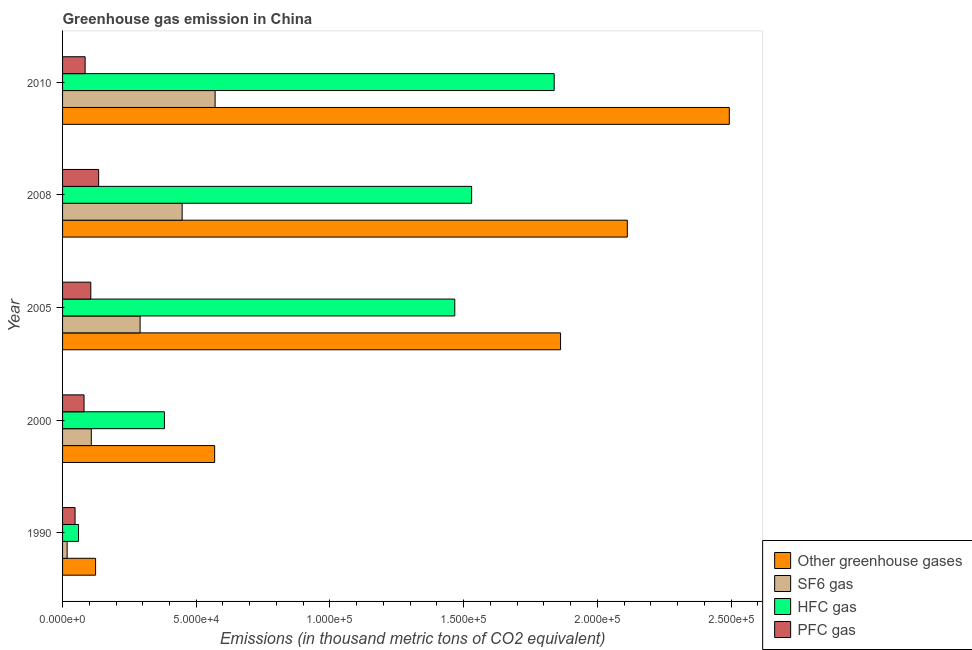How many bars are there on the 3rd tick from the bottom?
Keep it short and to the point. 4. What is the label of the 1st group of bars from the top?
Provide a short and direct response. 2010. What is the emission of hfc gas in 1990?
Offer a terse response. 5970.1. Across all years, what is the maximum emission of sf6 gas?
Keep it short and to the point. 5.71e+04. Across all years, what is the minimum emission of hfc gas?
Keep it short and to the point. 5970.1. In which year was the emission of pfc gas maximum?
Offer a terse response. 2008. What is the total emission of hfc gas in the graph?
Ensure brevity in your answer.  5.28e+05. What is the difference between the emission of greenhouse gases in 2008 and that in 2010?
Ensure brevity in your answer.  -3.81e+04. What is the difference between the emission of hfc gas in 2000 and the emission of sf6 gas in 2008?
Ensure brevity in your answer.  -6632.2. What is the average emission of sf6 gas per year?
Your answer should be compact. 2.86e+04. In the year 2010, what is the difference between the emission of hfc gas and emission of greenhouse gases?
Your answer should be compact. -6.55e+04. In how many years, is the emission of sf6 gas greater than 50000 thousand metric tons?
Provide a succinct answer. 1. What is the ratio of the emission of sf6 gas in 1990 to that in 2008?
Your response must be concise. 0.04. Is the emission of pfc gas in 1990 less than that in 2000?
Provide a short and direct response. Yes. Is the difference between the emission of pfc gas in 1990 and 2008 greater than the difference between the emission of sf6 gas in 1990 and 2008?
Make the answer very short. Yes. What is the difference between the highest and the second highest emission of pfc gas?
Your response must be concise. 2937.8. What is the difference between the highest and the lowest emission of sf6 gas?
Your answer should be compact. 5.53e+04. In how many years, is the emission of greenhouse gases greater than the average emission of greenhouse gases taken over all years?
Offer a very short reply. 3. Is the sum of the emission of sf6 gas in 2008 and 2010 greater than the maximum emission of hfc gas across all years?
Make the answer very short. No. What does the 2nd bar from the top in 2010 represents?
Your answer should be compact. HFC gas. What does the 2nd bar from the bottom in 2005 represents?
Your response must be concise. SF6 gas. How many bars are there?
Make the answer very short. 20. How many years are there in the graph?
Your answer should be compact. 5. What is the difference between two consecutive major ticks on the X-axis?
Give a very brief answer. 5.00e+04. Does the graph contain grids?
Your response must be concise. No. Where does the legend appear in the graph?
Your response must be concise. Bottom right. How many legend labels are there?
Make the answer very short. 4. What is the title of the graph?
Provide a succinct answer. Greenhouse gas emission in China. What is the label or title of the X-axis?
Ensure brevity in your answer.  Emissions (in thousand metric tons of CO2 equivalent). What is the label or title of the Y-axis?
Offer a terse response. Year. What is the Emissions (in thousand metric tons of CO2 equivalent) in Other greenhouse gases in 1990?
Your answer should be compact. 1.24e+04. What is the Emissions (in thousand metric tons of CO2 equivalent) in SF6 gas in 1990?
Give a very brief answer. 1708.6. What is the Emissions (in thousand metric tons of CO2 equivalent) of HFC gas in 1990?
Keep it short and to the point. 5970.1. What is the Emissions (in thousand metric tons of CO2 equivalent) of PFC gas in 1990?
Give a very brief answer. 4674.5. What is the Emissions (in thousand metric tons of CO2 equivalent) of Other greenhouse gases in 2000?
Your answer should be very brief. 5.69e+04. What is the Emissions (in thousand metric tons of CO2 equivalent) in SF6 gas in 2000?
Your response must be concise. 1.08e+04. What is the Emissions (in thousand metric tons of CO2 equivalent) of HFC gas in 2000?
Your answer should be compact. 3.81e+04. What is the Emissions (in thousand metric tons of CO2 equivalent) in PFC gas in 2000?
Offer a very short reply. 8034.4. What is the Emissions (in thousand metric tons of CO2 equivalent) in Other greenhouse gases in 2005?
Your answer should be very brief. 1.86e+05. What is the Emissions (in thousand metric tons of CO2 equivalent) in SF6 gas in 2005?
Offer a very short reply. 2.90e+04. What is the Emissions (in thousand metric tons of CO2 equivalent) of HFC gas in 2005?
Offer a very short reply. 1.47e+05. What is the Emissions (in thousand metric tons of CO2 equivalent) in PFC gas in 2005?
Give a very brief answer. 1.06e+04. What is the Emissions (in thousand metric tons of CO2 equivalent) of Other greenhouse gases in 2008?
Give a very brief answer. 2.11e+05. What is the Emissions (in thousand metric tons of CO2 equivalent) in SF6 gas in 2008?
Provide a short and direct response. 4.47e+04. What is the Emissions (in thousand metric tons of CO2 equivalent) in HFC gas in 2008?
Your answer should be compact. 1.53e+05. What is the Emissions (in thousand metric tons of CO2 equivalent) of PFC gas in 2008?
Give a very brief answer. 1.35e+04. What is the Emissions (in thousand metric tons of CO2 equivalent) in Other greenhouse gases in 2010?
Your response must be concise. 2.49e+05. What is the Emissions (in thousand metric tons of CO2 equivalent) in SF6 gas in 2010?
Your response must be concise. 5.71e+04. What is the Emissions (in thousand metric tons of CO2 equivalent) in HFC gas in 2010?
Provide a succinct answer. 1.84e+05. What is the Emissions (in thousand metric tons of CO2 equivalent) in PFC gas in 2010?
Give a very brief answer. 8438. Across all years, what is the maximum Emissions (in thousand metric tons of CO2 equivalent) of Other greenhouse gases?
Your response must be concise. 2.49e+05. Across all years, what is the maximum Emissions (in thousand metric tons of CO2 equivalent) in SF6 gas?
Give a very brief answer. 5.71e+04. Across all years, what is the maximum Emissions (in thousand metric tons of CO2 equivalent) in HFC gas?
Make the answer very short. 1.84e+05. Across all years, what is the maximum Emissions (in thousand metric tons of CO2 equivalent) of PFC gas?
Ensure brevity in your answer.  1.35e+04. Across all years, what is the minimum Emissions (in thousand metric tons of CO2 equivalent) of Other greenhouse gases?
Give a very brief answer. 1.24e+04. Across all years, what is the minimum Emissions (in thousand metric tons of CO2 equivalent) in SF6 gas?
Provide a succinct answer. 1708.6. Across all years, what is the minimum Emissions (in thousand metric tons of CO2 equivalent) of HFC gas?
Make the answer very short. 5970.1. Across all years, what is the minimum Emissions (in thousand metric tons of CO2 equivalent) in PFC gas?
Provide a short and direct response. 4674.5. What is the total Emissions (in thousand metric tons of CO2 equivalent) of Other greenhouse gases in the graph?
Ensure brevity in your answer.  7.16e+05. What is the total Emissions (in thousand metric tons of CO2 equivalent) of SF6 gas in the graph?
Provide a succinct answer. 1.43e+05. What is the total Emissions (in thousand metric tons of CO2 equivalent) of HFC gas in the graph?
Offer a terse response. 5.28e+05. What is the total Emissions (in thousand metric tons of CO2 equivalent) of PFC gas in the graph?
Give a very brief answer. 4.52e+04. What is the difference between the Emissions (in thousand metric tons of CO2 equivalent) of Other greenhouse gases in 1990 and that in 2000?
Your answer should be very brief. -4.45e+04. What is the difference between the Emissions (in thousand metric tons of CO2 equivalent) in SF6 gas in 1990 and that in 2000?
Provide a short and direct response. -9045. What is the difference between the Emissions (in thousand metric tons of CO2 equivalent) in HFC gas in 1990 and that in 2000?
Your answer should be compact. -3.21e+04. What is the difference between the Emissions (in thousand metric tons of CO2 equivalent) of PFC gas in 1990 and that in 2000?
Give a very brief answer. -3359.9. What is the difference between the Emissions (in thousand metric tons of CO2 equivalent) in Other greenhouse gases in 1990 and that in 2005?
Offer a terse response. -1.74e+05. What is the difference between the Emissions (in thousand metric tons of CO2 equivalent) of SF6 gas in 1990 and that in 2005?
Keep it short and to the point. -2.73e+04. What is the difference between the Emissions (in thousand metric tons of CO2 equivalent) of HFC gas in 1990 and that in 2005?
Give a very brief answer. -1.41e+05. What is the difference between the Emissions (in thousand metric tons of CO2 equivalent) in PFC gas in 1990 and that in 2005?
Your answer should be compact. -5888.3. What is the difference between the Emissions (in thousand metric tons of CO2 equivalent) in Other greenhouse gases in 1990 and that in 2008?
Your answer should be very brief. -1.99e+05. What is the difference between the Emissions (in thousand metric tons of CO2 equivalent) of SF6 gas in 1990 and that in 2008?
Provide a succinct answer. -4.30e+04. What is the difference between the Emissions (in thousand metric tons of CO2 equivalent) of HFC gas in 1990 and that in 2008?
Your answer should be very brief. -1.47e+05. What is the difference between the Emissions (in thousand metric tons of CO2 equivalent) in PFC gas in 1990 and that in 2008?
Your answer should be very brief. -8826.1. What is the difference between the Emissions (in thousand metric tons of CO2 equivalent) in Other greenhouse gases in 1990 and that in 2010?
Give a very brief answer. -2.37e+05. What is the difference between the Emissions (in thousand metric tons of CO2 equivalent) in SF6 gas in 1990 and that in 2010?
Give a very brief answer. -5.53e+04. What is the difference between the Emissions (in thousand metric tons of CO2 equivalent) in HFC gas in 1990 and that in 2010?
Your answer should be very brief. -1.78e+05. What is the difference between the Emissions (in thousand metric tons of CO2 equivalent) of PFC gas in 1990 and that in 2010?
Provide a short and direct response. -3763.5. What is the difference between the Emissions (in thousand metric tons of CO2 equivalent) in Other greenhouse gases in 2000 and that in 2005?
Offer a terse response. -1.29e+05. What is the difference between the Emissions (in thousand metric tons of CO2 equivalent) in SF6 gas in 2000 and that in 2005?
Your answer should be very brief. -1.82e+04. What is the difference between the Emissions (in thousand metric tons of CO2 equivalent) in HFC gas in 2000 and that in 2005?
Your response must be concise. -1.09e+05. What is the difference between the Emissions (in thousand metric tons of CO2 equivalent) in PFC gas in 2000 and that in 2005?
Your answer should be compact. -2528.4. What is the difference between the Emissions (in thousand metric tons of CO2 equivalent) in Other greenhouse gases in 2000 and that in 2008?
Provide a short and direct response. -1.54e+05. What is the difference between the Emissions (in thousand metric tons of CO2 equivalent) of SF6 gas in 2000 and that in 2008?
Keep it short and to the point. -3.40e+04. What is the difference between the Emissions (in thousand metric tons of CO2 equivalent) in HFC gas in 2000 and that in 2008?
Provide a short and direct response. -1.15e+05. What is the difference between the Emissions (in thousand metric tons of CO2 equivalent) of PFC gas in 2000 and that in 2008?
Keep it short and to the point. -5466.2. What is the difference between the Emissions (in thousand metric tons of CO2 equivalent) of Other greenhouse gases in 2000 and that in 2010?
Offer a very short reply. -1.92e+05. What is the difference between the Emissions (in thousand metric tons of CO2 equivalent) of SF6 gas in 2000 and that in 2010?
Your response must be concise. -4.63e+04. What is the difference between the Emissions (in thousand metric tons of CO2 equivalent) of HFC gas in 2000 and that in 2010?
Keep it short and to the point. -1.46e+05. What is the difference between the Emissions (in thousand metric tons of CO2 equivalent) of PFC gas in 2000 and that in 2010?
Provide a short and direct response. -403.6. What is the difference between the Emissions (in thousand metric tons of CO2 equivalent) in Other greenhouse gases in 2005 and that in 2008?
Your response must be concise. -2.50e+04. What is the difference between the Emissions (in thousand metric tons of CO2 equivalent) in SF6 gas in 2005 and that in 2008?
Your answer should be compact. -1.57e+04. What is the difference between the Emissions (in thousand metric tons of CO2 equivalent) of HFC gas in 2005 and that in 2008?
Keep it short and to the point. -6309. What is the difference between the Emissions (in thousand metric tons of CO2 equivalent) of PFC gas in 2005 and that in 2008?
Offer a very short reply. -2937.8. What is the difference between the Emissions (in thousand metric tons of CO2 equivalent) in Other greenhouse gases in 2005 and that in 2010?
Provide a short and direct response. -6.31e+04. What is the difference between the Emissions (in thousand metric tons of CO2 equivalent) of SF6 gas in 2005 and that in 2010?
Ensure brevity in your answer.  -2.81e+04. What is the difference between the Emissions (in thousand metric tons of CO2 equivalent) of HFC gas in 2005 and that in 2010?
Offer a terse response. -3.72e+04. What is the difference between the Emissions (in thousand metric tons of CO2 equivalent) in PFC gas in 2005 and that in 2010?
Provide a short and direct response. 2124.8. What is the difference between the Emissions (in thousand metric tons of CO2 equivalent) of Other greenhouse gases in 2008 and that in 2010?
Your answer should be compact. -3.81e+04. What is the difference between the Emissions (in thousand metric tons of CO2 equivalent) of SF6 gas in 2008 and that in 2010?
Keep it short and to the point. -1.23e+04. What is the difference between the Emissions (in thousand metric tons of CO2 equivalent) of HFC gas in 2008 and that in 2010?
Make the answer very short. -3.09e+04. What is the difference between the Emissions (in thousand metric tons of CO2 equivalent) in PFC gas in 2008 and that in 2010?
Your response must be concise. 5062.6. What is the difference between the Emissions (in thousand metric tons of CO2 equivalent) of Other greenhouse gases in 1990 and the Emissions (in thousand metric tons of CO2 equivalent) of SF6 gas in 2000?
Your answer should be very brief. 1599.6. What is the difference between the Emissions (in thousand metric tons of CO2 equivalent) of Other greenhouse gases in 1990 and the Emissions (in thousand metric tons of CO2 equivalent) of HFC gas in 2000?
Offer a very short reply. -2.57e+04. What is the difference between the Emissions (in thousand metric tons of CO2 equivalent) in Other greenhouse gases in 1990 and the Emissions (in thousand metric tons of CO2 equivalent) in PFC gas in 2000?
Provide a short and direct response. 4318.8. What is the difference between the Emissions (in thousand metric tons of CO2 equivalent) in SF6 gas in 1990 and the Emissions (in thousand metric tons of CO2 equivalent) in HFC gas in 2000?
Your response must be concise. -3.64e+04. What is the difference between the Emissions (in thousand metric tons of CO2 equivalent) in SF6 gas in 1990 and the Emissions (in thousand metric tons of CO2 equivalent) in PFC gas in 2000?
Offer a terse response. -6325.8. What is the difference between the Emissions (in thousand metric tons of CO2 equivalent) in HFC gas in 1990 and the Emissions (in thousand metric tons of CO2 equivalent) in PFC gas in 2000?
Provide a succinct answer. -2064.3. What is the difference between the Emissions (in thousand metric tons of CO2 equivalent) of Other greenhouse gases in 1990 and the Emissions (in thousand metric tons of CO2 equivalent) of SF6 gas in 2005?
Your answer should be compact. -1.66e+04. What is the difference between the Emissions (in thousand metric tons of CO2 equivalent) in Other greenhouse gases in 1990 and the Emissions (in thousand metric tons of CO2 equivalent) in HFC gas in 2005?
Keep it short and to the point. -1.34e+05. What is the difference between the Emissions (in thousand metric tons of CO2 equivalent) of Other greenhouse gases in 1990 and the Emissions (in thousand metric tons of CO2 equivalent) of PFC gas in 2005?
Ensure brevity in your answer.  1790.4. What is the difference between the Emissions (in thousand metric tons of CO2 equivalent) of SF6 gas in 1990 and the Emissions (in thousand metric tons of CO2 equivalent) of HFC gas in 2005?
Ensure brevity in your answer.  -1.45e+05. What is the difference between the Emissions (in thousand metric tons of CO2 equivalent) of SF6 gas in 1990 and the Emissions (in thousand metric tons of CO2 equivalent) of PFC gas in 2005?
Provide a succinct answer. -8854.2. What is the difference between the Emissions (in thousand metric tons of CO2 equivalent) of HFC gas in 1990 and the Emissions (in thousand metric tons of CO2 equivalent) of PFC gas in 2005?
Offer a terse response. -4592.7. What is the difference between the Emissions (in thousand metric tons of CO2 equivalent) in Other greenhouse gases in 1990 and the Emissions (in thousand metric tons of CO2 equivalent) in SF6 gas in 2008?
Your response must be concise. -3.24e+04. What is the difference between the Emissions (in thousand metric tons of CO2 equivalent) in Other greenhouse gases in 1990 and the Emissions (in thousand metric tons of CO2 equivalent) in HFC gas in 2008?
Ensure brevity in your answer.  -1.41e+05. What is the difference between the Emissions (in thousand metric tons of CO2 equivalent) in Other greenhouse gases in 1990 and the Emissions (in thousand metric tons of CO2 equivalent) in PFC gas in 2008?
Offer a terse response. -1147.4. What is the difference between the Emissions (in thousand metric tons of CO2 equivalent) in SF6 gas in 1990 and the Emissions (in thousand metric tons of CO2 equivalent) in HFC gas in 2008?
Make the answer very short. -1.51e+05. What is the difference between the Emissions (in thousand metric tons of CO2 equivalent) of SF6 gas in 1990 and the Emissions (in thousand metric tons of CO2 equivalent) of PFC gas in 2008?
Your answer should be compact. -1.18e+04. What is the difference between the Emissions (in thousand metric tons of CO2 equivalent) of HFC gas in 1990 and the Emissions (in thousand metric tons of CO2 equivalent) of PFC gas in 2008?
Your answer should be compact. -7530.5. What is the difference between the Emissions (in thousand metric tons of CO2 equivalent) in Other greenhouse gases in 1990 and the Emissions (in thousand metric tons of CO2 equivalent) in SF6 gas in 2010?
Provide a short and direct response. -4.47e+04. What is the difference between the Emissions (in thousand metric tons of CO2 equivalent) of Other greenhouse gases in 1990 and the Emissions (in thousand metric tons of CO2 equivalent) of HFC gas in 2010?
Keep it short and to the point. -1.72e+05. What is the difference between the Emissions (in thousand metric tons of CO2 equivalent) of Other greenhouse gases in 1990 and the Emissions (in thousand metric tons of CO2 equivalent) of PFC gas in 2010?
Ensure brevity in your answer.  3915.2. What is the difference between the Emissions (in thousand metric tons of CO2 equivalent) in SF6 gas in 1990 and the Emissions (in thousand metric tons of CO2 equivalent) in HFC gas in 2010?
Provide a short and direct response. -1.82e+05. What is the difference between the Emissions (in thousand metric tons of CO2 equivalent) of SF6 gas in 1990 and the Emissions (in thousand metric tons of CO2 equivalent) of PFC gas in 2010?
Provide a succinct answer. -6729.4. What is the difference between the Emissions (in thousand metric tons of CO2 equivalent) of HFC gas in 1990 and the Emissions (in thousand metric tons of CO2 equivalent) of PFC gas in 2010?
Your answer should be very brief. -2467.9. What is the difference between the Emissions (in thousand metric tons of CO2 equivalent) of Other greenhouse gases in 2000 and the Emissions (in thousand metric tons of CO2 equivalent) of SF6 gas in 2005?
Give a very brief answer. 2.79e+04. What is the difference between the Emissions (in thousand metric tons of CO2 equivalent) in Other greenhouse gases in 2000 and the Emissions (in thousand metric tons of CO2 equivalent) in HFC gas in 2005?
Make the answer very short. -8.98e+04. What is the difference between the Emissions (in thousand metric tons of CO2 equivalent) in Other greenhouse gases in 2000 and the Emissions (in thousand metric tons of CO2 equivalent) in PFC gas in 2005?
Give a very brief answer. 4.63e+04. What is the difference between the Emissions (in thousand metric tons of CO2 equivalent) in SF6 gas in 2000 and the Emissions (in thousand metric tons of CO2 equivalent) in HFC gas in 2005?
Offer a very short reply. -1.36e+05. What is the difference between the Emissions (in thousand metric tons of CO2 equivalent) in SF6 gas in 2000 and the Emissions (in thousand metric tons of CO2 equivalent) in PFC gas in 2005?
Provide a succinct answer. 190.8. What is the difference between the Emissions (in thousand metric tons of CO2 equivalent) of HFC gas in 2000 and the Emissions (in thousand metric tons of CO2 equivalent) of PFC gas in 2005?
Your answer should be very brief. 2.75e+04. What is the difference between the Emissions (in thousand metric tons of CO2 equivalent) in Other greenhouse gases in 2000 and the Emissions (in thousand metric tons of CO2 equivalent) in SF6 gas in 2008?
Your answer should be very brief. 1.22e+04. What is the difference between the Emissions (in thousand metric tons of CO2 equivalent) in Other greenhouse gases in 2000 and the Emissions (in thousand metric tons of CO2 equivalent) in HFC gas in 2008?
Your response must be concise. -9.61e+04. What is the difference between the Emissions (in thousand metric tons of CO2 equivalent) in Other greenhouse gases in 2000 and the Emissions (in thousand metric tons of CO2 equivalent) in PFC gas in 2008?
Make the answer very short. 4.34e+04. What is the difference between the Emissions (in thousand metric tons of CO2 equivalent) in SF6 gas in 2000 and the Emissions (in thousand metric tons of CO2 equivalent) in HFC gas in 2008?
Provide a succinct answer. -1.42e+05. What is the difference between the Emissions (in thousand metric tons of CO2 equivalent) in SF6 gas in 2000 and the Emissions (in thousand metric tons of CO2 equivalent) in PFC gas in 2008?
Keep it short and to the point. -2747. What is the difference between the Emissions (in thousand metric tons of CO2 equivalent) of HFC gas in 2000 and the Emissions (in thousand metric tons of CO2 equivalent) of PFC gas in 2008?
Provide a short and direct response. 2.46e+04. What is the difference between the Emissions (in thousand metric tons of CO2 equivalent) in Other greenhouse gases in 2000 and the Emissions (in thousand metric tons of CO2 equivalent) in SF6 gas in 2010?
Your answer should be compact. -172. What is the difference between the Emissions (in thousand metric tons of CO2 equivalent) in Other greenhouse gases in 2000 and the Emissions (in thousand metric tons of CO2 equivalent) in HFC gas in 2010?
Provide a short and direct response. -1.27e+05. What is the difference between the Emissions (in thousand metric tons of CO2 equivalent) of Other greenhouse gases in 2000 and the Emissions (in thousand metric tons of CO2 equivalent) of PFC gas in 2010?
Give a very brief answer. 4.84e+04. What is the difference between the Emissions (in thousand metric tons of CO2 equivalent) in SF6 gas in 2000 and the Emissions (in thousand metric tons of CO2 equivalent) in HFC gas in 2010?
Offer a terse response. -1.73e+05. What is the difference between the Emissions (in thousand metric tons of CO2 equivalent) of SF6 gas in 2000 and the Emissions (in thousand metric tons of CO2 equivalent) of PFC gas in 2010?
Your response must be concise. 2315.6. What is the difference between the Emissions (in thousand metric tons of CO2 equivalent) of HFC gas in 2000 and the Emissions (in thousand metric tons of CO2 equivalent) of PFC gas in 2010?
Make the answer very short. 2.97e+04. What is the difference between the Emissions (in thousand metric tons of CO2 equivalent) of Other greenhouse gases in 2005 and the Emissions (in thousand metric tons of CO2 equivalent) of SF6 gas in 2008?
Offer a terse response. 1.42e+05. What is the difference between the Emissions (in thousand metric tons of CO2 equivalent) in Other greenhouse gases in 2005 and the Emissions (in thousand metric tons of CO2 equivalent) in HFC gas in 2008?
Offer a very short reply. 3.33e+04. What is the difference between the Emissions (in thousand metric tons of CO2 equivalent) in Other greenhouse gases in 2005 and the Emissions (in thousand metric tons of CO2 equivalent) in PFC gas in 2008?
Offer a terse response. 1.73e+05. What is the difference between the Emissions (in thousand metric tons of CO2 equivalent) in SF6 gas in 2005 and the Emissions (in thousand metric tons of CO2 equivalent) in HFC gas in 2008?
Provide a succinct answer. -1.24e+05. What is the difference between the Emissions (in thousand metric tons of CO2 equivalent) in SF6 gas in 2005 and the Emissions (in thousand metric tons of CO2 equivalent) in PFC gas in 2008?
Give a very brief answer. 1.55e+04. What is the difference between the Emissions (in thousand metric tons of CO2 equivalent) of HFC gas in 2005 and the Emissions (in thousand metric tons of CO2 equivalent) of PFC gas in 2008?
Keep it short and to the point. 1.33e+05. What is the difference between the Emissions (in thousand metric tons of CO2 equivalent) in Other greenhouse gases in 2005 and the Emissions (in thousand metric tons of CO2 equivalent) in SF6 gas in 2010?
Make the answer very short. 1.29e+05. What is the difference between the Emissions (in thousand metric tons of CO2 equivalent) in Other greenhouse gases in 2005 and the Emissions (in thousand metric tons of CO2 equivalent) in HFC gas in 2010?
Offer a very short reply. 2383.5. What is the difference between the Emissions (in thousand metric tons of CO2 equivalent) in Other greenhouse gases in 2005 and the Emissions (in thousand metric tons of CO2 equivalent) in PFC gas in 2010?
Give a very brief answer. 1.78e+05. What is the difference between the Emissions (in thousand metric tons of CO2 equivalent) of SF6 gas in 2005 and the Emissions (in thousand metric tons of CO2 equivalent) of HFC gas in 2010?
Provide a succinct answer. -1.55e+05. What is the difference between the Emissions (in thousand metric tons of CO2 equivalent) in SF6 gas in 2005 and the Emissions (in thousand metric tons of CO2 equivalent) in PFC gas in 2010?
Provide a short and direct response. 2.06e+04. What is the difference between the Emissions (in thousand metric tons of CO2 equivalent) in HFC gas in 2005 and the Emissions (in thousand metric tons of CO2 equivalent) in PFC gas in 2010?
Your response must be concise. 1.38e+05. What is the difference between the Emissions (in thousand metric tons of CO2 equivalent) of Other greenhouse gases in 2008 and the Emissions (in thousand metric tons of CO2 equivalent) of SF6 gas in 2010?
Ensure brevity in your answer.  1.54e+05. What is the difference between the Emissions (in thousand metric tons of CO2 equivalent) in Other greenhouse gases in 2008 and the Emissions (in thousand metric tons of CO2 equivalent) in HFC gas in 2010?
Make the answer very short. 2.74e+04. What is the difference between the Emissions (in thousand metric tons of CO2 equivalent) in Other greenhouse gases in 2008 and the Emissions (in thousand metric tons of CO2 equivalent) in PFC gas in 2010?
Your response must be concise. 2.03e+05. What is the difference between the Emissions (in thousand metric tons of CO2 equivalent) of SF6 gas in 2008 and the Emissions (in thousand metric tons of CO2 equivalent) of HFC gas in 2010?
Your response must be concise. -1.39e+05. What is the difference between the Emissions (in thousand metric tons of CO2 equivalent) of SF6 gas in 2008 and the Emissions (in thousand metric tons of CO2 equivalent) of PFC gas in 2010?
Your response must be concise. 3.63e+04. What is the difference between the Emissions (in thousand metric tons of CO2 equivalent) of HFC gas in 2008 and the Emissions (in thousand metric tons of CO2 equivalent) of PFC gas in 2010?
Offer a terse response. 1.45e+05. What is the average Emissions (in thousand metric tons of CO2 equivalent) in Other greenhouse gases per year?
Keep it short and to the point. 1.43e+05. What is the average Emissions (in thousand metric tons of CO2 equivalent) of SF6 gas per year?
Your response must be concise. 2.86e+04. What is the average Emissions (in thousand metric tons of CO2 equivalent) of HFC gas per year?
Your answer should be very brief. 1.06e+05. What is the average Emissions (in thousand metric tons of CO2 equivalent) of PFC gas per year?
Keep it short and to the point. 9042.06. In the year 1990, what is the difference between the Emissions (in thousand metric tons of CO2 equivalent) in Other greenhouse gases and Emissions (in thousand metric tons of CO2 equivalent) in SF6 gas?
Give a very brief answer. 1.06e+04. In the year 1990, what is the difference between the Emissions (in thousand metric tons of CO2 equivalent) of Other greenhouse gases and Emissions (in thousand metric tons of CO2 equivalent) of HFC gas?
Ensure brevity in your answer.  6383.1. In the year 1990, what is the difference between the Emissions (in thousand metric tons of CO2 equivalent) of Other greenhouse gases and Emissions (in thousand metric tons of CO2 equivalent) of PFC gas?
Make the answer very short. 7678.7. In the year 1990, what is the difference between the Emissions (in thousand metric tons of CO2 equivalent) of SF6 gas and Emissions (in thousand metric tons of CO2 equivalent) of HFC gas?
Make the answer very short. -4261.5. In the year 1990, what is the difference between the Emissions (in thousand metric tons of CO2 equivalent) of SF6 gas and Emissions (in thousand metric tons of CO2 equivalent) of PFC gas?
Make the answer very short. -2965.9. In the year 1990, what is the difference between the Emissions (in thousand metric tons of CO2 equivalent) in HFC gas and Emissions (in thousand metric tons of CO2 equivalent) in PFC gas?
Your response must be concise. 1295.6. In the year 2000, what is the difference between the Emissions (in thousand metric tons of CO2 equivalent) of Other greenhouse gases and Emissions (in thousand metric tons of CO2 equivalent) of SF6 gas?
Your answer should be very brief. 4.61e+04. In the year 2000, what is the difference between the Emissions (in thousand metric tons of CO2 equivalent) of Other greenhouse gases and Emissions (in thousand metric tons of CO2 equivalent) of HFC gas?
Offer a terse response. 1.88e+04. In the year 2000, what is the difference between the Emissions (in thousand metric tons of CO2 equivalent) in Other greenhouse gases and Emissions (in thousand metric tons of CO2 equivalent) in PFC gas?
Give a very brief answer. 4.88e+04. In the year 2000, what is the difference between the Emissions (in thousand metric tons of CO2 equivalent) of SF6 gas and Emissions (in thousand metric tons of CO2 equivalent) of HFC gas?
Provide a short and direct response. -2.73e+04. In the year 2000, what is the difference between the Emissions (in thousand metric tons of CO2 equivalent) in SF6 gas and Emissions (in thousand metric tons of CO2 equivalent) in PFC gas?
Provide a succinct answer. 2719.2. In the year 2000, what is the difference between the Emissions (in thousand metric tons of CO2 equivalent) in HFC gas and Emissions (in thousand metric tons of CO2 equivalent) in PFC gas?
Your response must be concise. 3.01e+04. In the year 2005, what is the difference between the Emissions (in thousand metric tons of CO2 equivalent) of Other greenhouse gases and Emissions (in thousand metric tons of CO2 equivalent) of SF6 gas?
Your answer should be compact. 1.57e+05. In the year 2005, what is the difference between the Emissions (in thousand metric tons of CO2 equivalent) of Other greenhouse gases and Emissions (in thousand metric tons of CO2 equivalent) of HFC gas?
Your answer should be very brief. 3.96e+04. In the year 2005, what is the difference between the Emissions (in thousand metric tons of CO2 equivalent) in Other greenhouse gases and Emissions (in thousand metric tons of CO2 equivalent) in PFC gas?
Make the answer very short. 1.76e+05. In the year 2005, what is the difference between the Emissions (in thousand metric tons of CO2 equivalent) in SF6 gas and Emissions (in thousand metric tons of CO2 equivalent) in HFC gas?
Keep it short and to the point. -1.18e+05. In the year 2005, what is the difference between the Emissions (in thousand metric tons of CO2 equivalent) in SF6 gas and Emissions (in thousand metric tons of CO2 equivalent) in PFC gas?
Make the answer very short. 1.84e+04. In the year 2005, what is the difference between the Emissions (in thousand metric tons of CO2 equivalent) in HFC gas and Emissions (in thousand metric tons of CO2 equivalent) in PFC gas?
Offer a very short reply. 1.36e+05. In the year 2008, what is the difference between the Emissions (in thousand metric tons of CO2 equivalent) of Other greenhouse gases and Emissions (in thousand metric tons of CO2 equivalent) of SF6 gas?
Make the answer very short. 1.66e+05. In the year 2008, what is the difference between the Emissions (in thousand metric tons of CO2 equivalent) of Other greenhouse gases and Emissions (in thousand metric tons of CO2 equivalent) of HFC gas?
Keep it short and to the point. 5.82e+04. In the year 2008, what is the difference between the Emissions (in thousand metric tons of CO2 equivalent) of Other greenhouse gases and Emissions (in thousand metric tons of CO2 equivalent) of PFC gas?
Provide a short and direct response. 1.98e+05. In the year 2008, what is the difference between the Emissions (in thousand metric tons of CO2 equivalent) in SF6 gas and Emissions (in thousand metric tons of CO2 equivalent) in HFC gas?
Provide a short and direct response. -1.08e+05. In the year 2008, what is the difference between the Emissions (in thousand metric tons of CO2 equivalent) of SF6 gas and Emissions (in thousand metric tons of CO2 equivalent) of PFC gas?
Ensure brevity in your answer.  3.12e+04. In the year 2008, what is the difference between the Emissions (in thousand metric tons of CO2 equivalent) in HFC gas and Emissions (in thousand metric tons of CO2 equivalent) in PFC gas?
Your response must be concise. 1.39e+05. In the year 2010, what is the difference between the Emissions (in thousand metric tons of CO2 equivalent) in Other greenhouse gases and Emissions (in thousand metric tons of CO2 equivalent) in SF6 gas?
Keep it short and to the point. 1.92e+05. In the year 2010, what is the difference between the Emissions (in thousand metric tons of CO2 equivalent) of Other greenhouse gases and Emissions (in thousand metric tons of CO2 equivalent) of HFC gas?
Your response must be concise. 6.55e+04. In the year 2010, what is the difference between the Emissions (in thousand metric tons of CO2 equivalent) of Other greenhouse gases and Emissions (in thousand metric tons of CO2 equivalent) of PFC gas?
Ensure brevity in your answer.  2.41e+05. In the year 2010, what is the difference between the Emissions (in thousand metric tons of CO2 equivalent) of SF6 gas and Emissions (in thousand metric tons of CO2 equivalent) of HFC gas?
Ensure brevity in your answer.  -1.27e+05. In the year 2010, what is the difference between the Emissions (in thousand metric tons of CO2 equivalent) in SF6 gas and Emissions (in thousand metric tons of CO2 equivalent) in PFC gas?
Give a very brief answer. 4.86e+04. In the year 2010, what is the difference between the Emissions (in thousand metric tons of CO2 equivalent) of HFC gas and Emissions (in thousand metric tons of CO2 equivalent) of PFC gas?
Ensure brevity in your answer.  1.75e+05. What is the ratio of the Emissions (in thousand metric tons of CO2 equivalent) in Other greenhouse gases in 1990 to that in 2000?
Offer a very short reply. 0.22. What is the ratio of the Emissions (in thousand metric tons of CO2 equivalent) of SF6 gas in 1990 to that in 2000?
Give a very brief answer. 0.16. What is the ratio of the Emissions (in thousand metric tons of CO2 equivalent) of HFC gas in 1990 to that in 2000?
Provide a short and direct response. 0.16. What is the ratio of the Emissions (in thousand metric tons of CO2 equivalent) of PFC gas in 1990 to that in 2000?
Give a very brief answer. 0.58. What is the ratio of the Emissions (in thousand metric tons of CO2 equivalent) of Other greenhouse gases in 1990 to that in 2005?
Ensure brevity in your answer.  0.07. What is the ratio of the Emissions (in thousand metric tons of CO2 equivalent) in SF6 gas in 1990 to that in 2005?
Your answer should be compact. 0.06. What is the ratio of the Emissions (in thousand metric tons of CO2 equivalent) of HFC gas in 1990 to that in 2005?
Provide a short and direct response. 0.04. What is the ratio of the Emissions (in thousand metric tons of CO2 equivalent) of PFC gas in 1990 to that in 2005?
Offer a very short reply. 0.44. What is the ratio of the Emissions (in thousand metric tons of CO2 equivalent) in Other greenhouse gases in 1990 to that in 2008?
Make the answer very short. 0.06. What is the ratio of the Emissions (in thousand metric tons of CO2 equivalent) in SF6 gas in 1990 to that in 2008?
Offer a very short reply. 0.04. What is the ratio of the Emissions (in thousand metric tons of CO2 equivalent) in HFC gas in 1990 to that in 2008?
Your answer should be compact. 0.04. What is the ratio of the Emissions (in thousand metric tons of CO2 equivalent) in PFC gas in 1990 to that in 2008?
Offer a terse response. 0.35. What is the ratio of the Emissions (in thousand metric tons of CO2 equivalent) of Other greenhouse gases in 1990 to that in 2010?
Provide a short and direct response. 0.05. What is the ratio of the Emissions (in thousand metric tons of CO2 equivalent) in SF6 gas in 1990 to that in 2010?
Provide a short and direct response. 0.03. What is the ratio of the Emissions (in thousand metric tons of CO2 equivalent) of HFC gas in 1990 to that in 2010?
Make the answer very short. 0.03. What is the ratio of the Emissions (in thousand metric tons of CO2 equivalent) of PFC gas in 1990 to that in 2010?
Offer a terse response. 0.55. What is the ratio of the Emissions (in thousand metric tons of CO2 equivalent) in Other greenhouse gases in 2000 to that in 2005?
Offer a terse response. 0.31. What is the ratio of the Emissions (in thousand metric tons of CO2 equivalent) in SF6 gas in 2000 to that in 2005?
Your answer should be very brief. 0.37. What is the ratio of the Emissions (in thousand metric tons of CO2 equivalent) of HFC gas in 2000 to that in 2005?
Provide a succinct answer. 0.26. What is the ratio of the Emissions (in thousand metric tons of CO2 equivalent) of PFC gas in 2000 to that in 2005?
Keep it short and to the point. 0.76. What is the ratio of the Emissions (in thousand metric tons of CO2 equivalent) in Other greenhouse gases in 2000 to that in 2008?
Ensure brevity in your answer.  0.27. What is the ratio of the Emissions (in thousand metric tons of CO2 equivalent) in SF6 gas in 2000 to that in 2008?
Ensure brevity in your answer.  0.24. What is the ratio of the Emissions (in thousand metric tons of CO2 equivalent) of HFC gas in 2000 to that in 2008?
Give a very brief answer. 0.25. What is the ratio of the Emissions (in thousand metric tons of CO2 equivalent) in PFC gas in 2000 to that in 2008?
Give a very brief answer. 0.6. What is the ratio of the Emissions (in thousand metric tons of CO2 equivalent) in Other greenhouse gases in 2000 to that in 2010?
Keep it short and to the point. 0.23. What is the ratio of the Emissions (in thousand metric tons of CO2 equivalent) in SF6 gas in 2000 to that in 2010?
Ensure brevity in your answer.  0.19. What is the ratio of the Emissions (in thousand metric tons of CO2 equivalent) of HFC gas in 2000 to that in 2010?
Give a very brief answer. 0.21. What is the ratio of the Emissions (in thousand metric tons of CO2 equivalent) of PFC gas in 2000 to that in 2010?
Give a very brief answer. 0.95. What is the ratio of the Emissions (in thousand metric tons of CO2 equivalent) in Other greenhouse gases in 2005 to that in 2008?
Provide a succinct answer. 0.88. What is the ratio of the Emissions (in thousand metric tons of CO2 equivalent) in SF6 gas in 2005 to that in 2008?
Offer a terse response. 0.65. What is the ratio of the Emissions (in thousand metric tons of CO2 equivalent) in HFC gas in 2005 to that in 2008?
Provide a succinct answer. 0.96. What is the ratio of the Emissions (in thousand metric tons of CO2 equivalent) in PFC gas in 2005 to that in 2008?
Ensure brevity in your answer.  0.78. What is the ratio of the Emissions (in thousand metric tons of CO2 equivalent) in Other greenhouse gases in 2005 to that in 2010?
Offer a very short reply. 0.75. What is the ratio of the Emissions (in thousand metric tons of CO2 equivalent) in SF6 gas in 2005 to that in 2010?
Make the answer very short. 0.51. What is the ratio of the Emissions (in thousand metric tons of CO2 equivalent) in HFC gas in 2005 to that in 2010?
Your answer should be very brief. 0.8. What is the ratio of the Emissions (in thousand metric tons of CO2 equivalent) in PFC gas in 2005 to that in 2010?
Give a very brief answer. 1.25. What is the ratio of the Emissions (in thousand metric tons of CO2 equivalent) in Other greenhouse gases in 2008 to that in 2010?
Offer a terse response. 0.85. What is the ratio of the Emissions (in thousand metric tons of CO2 equivalent) of SF6 gas in 2008 to that in 2010?
Provide a succinct answer. 0.78. What is the ratio of the Emissions (in thousand metric tons of CO2 equivalent) of HFC gas in 2008 to that in 2010?
Your answer should be very brief. 0.83. What is the difference between the highest and the second highest Emissions (in thousand metric tons of CO2 equivalent) in Other greenhouse gases?
Your answer should be very brief. 3.81e+04. What is the difference between the highest and the second highest Emissions (in thousand metric tons of CO2 equivalent) of SF6 gas?
Your response must be concise. 1.23e+04. What is the difference between the highest and the second highest Emissions (in thousand metric tons of CO2 equivalent) in HFC gas?
Your answer should be compact. 3.09e+04. What is the difference between the highest and the second highest Emissions (in thousand metric tons of CO2 equivalent) of PFC gas?
Offer a very short reply. 2937.8. What is the difference between the highest and the lowest Emissions (in thousand metric tons of CO2 equivalent) in Other greenhouse gases?
Keep it short and to the point. 2.37e+05. What is the difference between the highest and the lowest Emissions (in thousand metric tons of CO2 equivalent) in SF6 gas?
Make the answer very short. 5.53e+04. What is the difference between the highest and the lowest Emissions (in thousand metric tons of CO2 equivalent) in HFC gas?
Make the answer very short. 1.78e+05. What is the difference between the highest and the lowest Emissions (in thousand metric tons of CO2 equivalent) of PFC gas?
Offer a very short reply. 8826.1. 